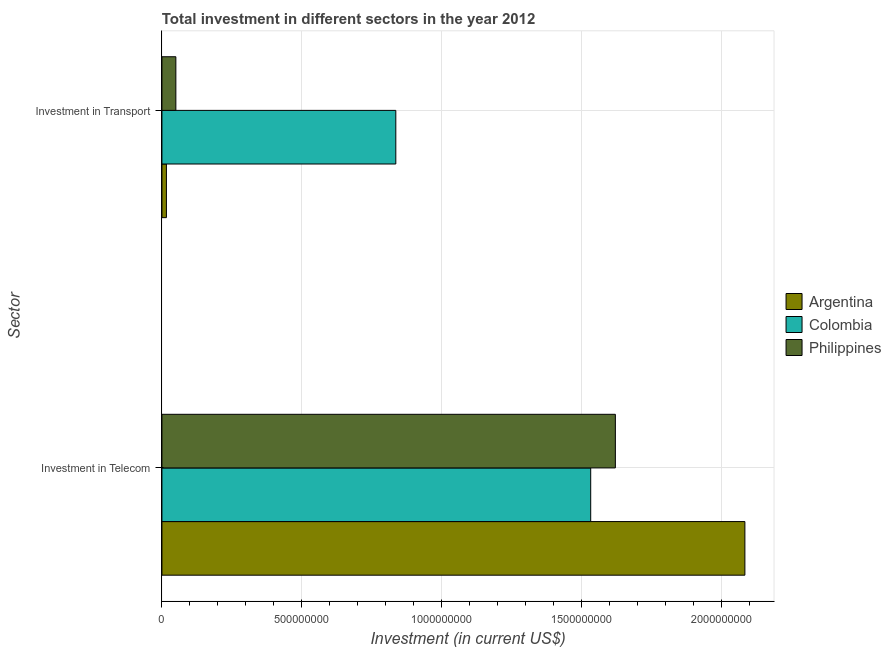How many different coloured bars are there?
Provide a succinct answer. 3. How many groups of bars are there?
Keep it short and to the point. 2. Are the number of bars per tick equal to the number of legend labels?
Give a very brief answer. Yes. Are the number of bars on each tick of the Y-axis equal?
Make the answer very short. Yes. How many bars are there on the 1st tick from the bottom?
Make the answer very short. 3. What is the label of the 2nd group of bars from the top?
Keep it short and to the point. Investment in Telecom. What is the investment in transport in Colombia?
Give a very brief answer. 8.35e+08. Across all countries, what is the maximum investment in transport?
Your response must be concise. 8.35e+08. Across all countries, what is the minimum investment in telecom?
Provide a short and direct response. 1.53e+09. In which country was the investment in transport maximum?
Provide a succinct answer. Colombia. What is the total investment in telecom in the graph?
Provide a succinct answer. 5.23e+09. What is the difference between the investment in telecom in Philippines and that in Colombia?
Your response must be concise. 8.81e+07. What is the difference between the investment in transport in Philippines and the investment in telecom in Argentina?
Keep it short and to the point. -2.03e+09. What is the average investment in transport per country?
Provide a short and direct response. 3.00e+08. What is the difference between the investment in transport and investment in telecom in Argentina?
Your answer should be compact. -2.07e+09. What is the ratio of the investment in transport in Argentina to that in Colombia?
Keep it short and to the point. 0.02. Is the investment in transport in Argentina less than that in Colombia?
Ensure brevity in your answer.  Yes. What does the 3rd bar from the top in Investment in Telecom represents?
Your response must be concise. Argentina. What does the 2nd bar from the bottom in Investment in Transport represents?
Offer a very short reply. Colombia. Are all the bars in the graph horizontal?
Your answer should be very brief. Yes. How many countries are there in the graph?
Make the answer very short. 3. What is the difference between two consecutive major ticks on the X-axis?
Your response must be concise. 5.00e+08. Does the graph contain any zero values?
Offer a very short reply. No. Does the graph contain grids?
Offer a very short reply. Yes. How many legend labels are there?
Provide a succinct answer. 3. What is the title of the graph?
Provide a short and direct response. Total investment in different sectors in the year 2012. Does "Korea (Republic)" appear as one of the legend labels in the graph?
Give a very brief answer. No. What is the label or title of the X-axis?
Your answer should be very brief. Investment (in current US$). What is the label or title of the Y-axis?
Make the answer very short. Sector. What is the Investment (in current US$) of Argentina in Investment in Telecom?
Provide a succinct answer. 2.08e+09. What is the Investment (in current US$) of Colombia in Investment in Telecom?
Provide a succinct answer. 1.53e+09. What is the Investment (in current US$) of Philippines in Investment in Telecom?
Your answer should be very brief. 1.62e+09. What is the Investment (in current US$) of Argentina in Investment in Transport?
Your answer should be compact. 1.60e+07. What is the Investment (in current US$) of Colombia in Investment in Transport?
Your answer should be compact. 8.35e+08. What is the Investment (in current US$) in Philippines in Investment in Transport?
Offer a very short reply. 4.97e+07. Across all Sector, what is the maximum Investment (in current US$) in Argentina?
Offer a terse response. 2.08e+09. Across all Sector, what is the maximum Investment (in current US$) of Colombia?
Provide a short and direct response. 1.53e+09. Across all Sector, what is the maximum Investment (in current US$) of Philippines?
Ensure brevity in your answer.  1.62e+09. Across all Sector, what is the minimum Investment (in current US$) of Argentina?
Your response must be concise. 1.60e+07. Across all Sector, what is the minimum Investment (in current US$) in Colombia?
Provide a succinct answer. 8.35e+08. Across all Sector, what is the minimum Investment (in current US$) in Philippines?
Provide a succinct answer. 4.97e+07. What is the total Investment (in current US$) in Argentina in the graph?
Keep it short and to the point. 2.10e+09. What is the total Investment (in current US$) of Colombia in the graph?
Provide a succinct answer. 2.37e+09. What is the total Investment (in current US$) in Philippines in the graph?
Keep it short and to the point. 1.67e+09. What is the difference between the Investment (in current US$) in Argentina in Investment in Telecom and that in Investment in Transport?
Ensure brevity in your answer.  2.07e+09. What is the difference between the Investment (in current US$) in Colombia in Investment in Telecom and that in Investment in Transport?
Your answer should be compact. 6.96e+08. What is the difference between the Investment (in current US$) in Philippines in Investment in Telecom and that in Investment in Transport?
Ensure brevity in your answer.  1.57e+09. What is the difference between the Investment (in current US$) in Argentina in Investment in Telecom and the Investment (in current US$) in Colombia in Investment in Transport?
Ensure brevity in your answer.  1.25e+09. What is the difference between the Investment (in current US$) of Argentina in Investment in Telecom and the Investment (in current US$) of Philippines in Investment in Transport?
Keep it short and to the point. 2.03e+09. What is the difference between the Investment (in current US$) in Colombia in Investment in Telecom and the Investment (in current US$) in Philippines in Investment in Transport?
Provide a succinct answer. 1.48e+09. What is the average Investment (in current US$) of Argentina per Sector?
Keep it short and to the point. 1.05e+09. What is the average Investment (in current US$) in Colombia per Sector?
Your answer should be compact. 1.18e+09. What is the average Investment (in current US$) in Philippines per Sector?
Your answer should be compact. 8.35e+08. What is the difference between the Investment (in current US$) of Argentina and Investment (in current US$) of Colombia in Investment in Telecom?
Offer a very short reply. 5.51e+08. What is the difference between the Investment (in current US$) in Argentina and Investment (in current US$) in Philippines in Investment in Telecom?
Keep it short and to the point. 4.63e+08. What is the difference between the Investment (in current US$) in Colombia and Investment (in current US$) in Philippines in Investment in Telecom?
Your answer should be compact. -8.81e+07. What is the difference between the Investment (in current US$) in Argentina and Investment (in current US$) in Colombia in Investment in Transport?
Ensure brevity in your answer.  -8.19e+08. What is the difference between the Investment (in current US$) in Argentina and Investment (in current US$) in Philippines in Investment in Transport?
Offer a very short reply. -3.37e+07. What is the difference between the Investment (in current US$) in Colombia and Investment (in current US$) in Philippines in Investment in Transport?
Provide a short and direct response. 7.86e+08. What is the ratio of the Investment (in current US$) of Argentina in Investment in Telecom to that in Investment in Transport?
Your answer should be very brief. 130.15. What is the ratio of the Investment (in current US$) of Colombia in Investment in Telecom to that in Investment in Transport?
Your answer should be very brief. 1.83. What is the ratio of the Investment (in current US$) in Philippines in Investment in Telecom to that in Investment in Transport?
Keep it short and to the point. 32.59. What is the difference between the highest and the second highest Investment (in current US$) in Argentina?
Offer a terse response. 2.07e+09. What is the difference between the highest and the second highest Investment (in current US$) in Colombia?
Your answer should be very brief. 6.96e+08. What is the difference between the highest and the second highest Investment (in current US$) of Philippines?
Your response must be concise. 1.57e+09. What is the difference between the highest and the lowest Investment (in current US$) in Argentina?
Your answer should be compact. 2.07e+09. What is the difference between the highest and the lowest Investment (in current US$) in Colombia?
Keep it short and to the point. 6.96e+08. What is the difference between the highest and the lowest Investment (in current US$) in Philippines?
Offer a terse response. 1.57e+09. 